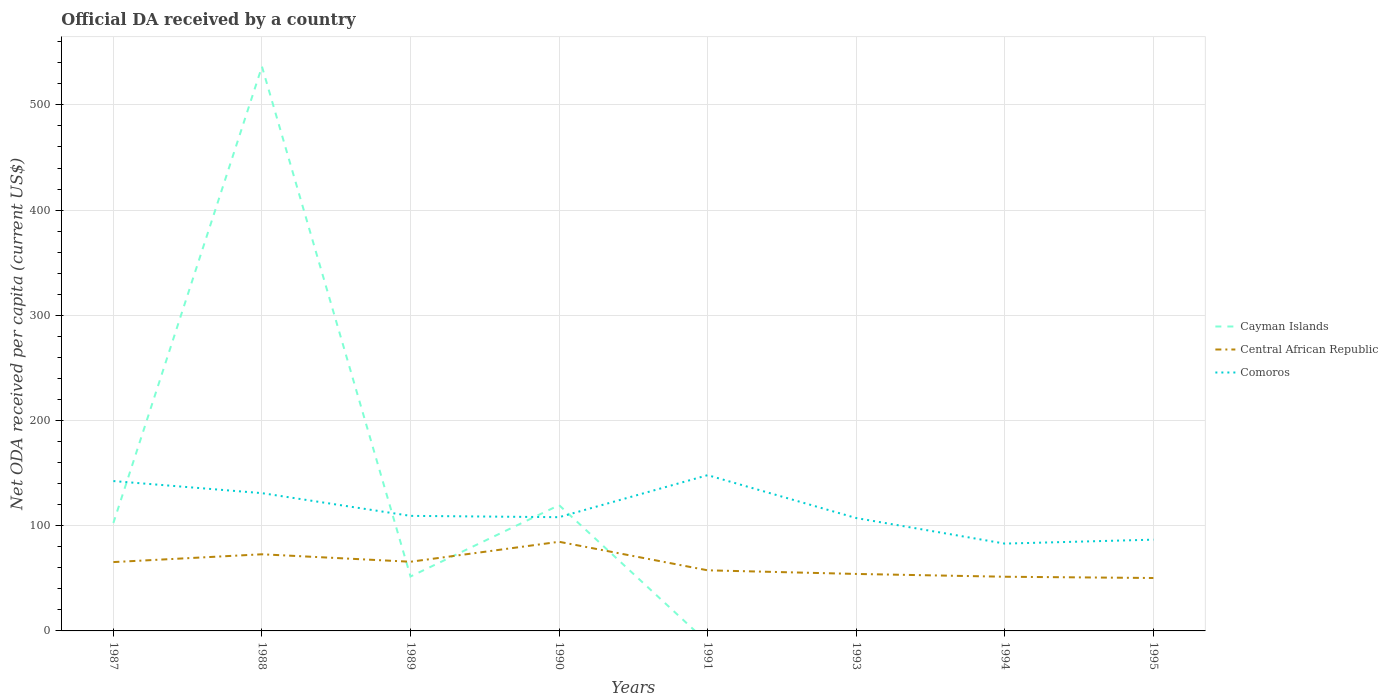Does the line corresponding to Comoros intersect with the line corresponding to Central African Republic?
Give a very brief answer. No. Across all years, what is the maximum ODA received in in Comoros?
Your response must be concise. 82.99. What is the total ODA received in in Comoros in the graph?
Provide a short and direct response. 25.11. What is the difference between the highest and the second highest ODA received in in Comoros?
Give a very brief answer. 65.06. What is the difference between the highest and the lowest ODA received in in Comoros?
Make the answer very short. 3. Are the values on the major ticks of Y-axis written in scientific E-notation?
Provide a short and direct response. No. Does the graph contain grids?
Offer a very short reply. Yes. How many legend labels are there?
Provide a short and direct response. 3. How are the legend labels stacked?
Make the answer very short. Vertical. What is the title of the graph?
Your response must be concise. Official DA received by a country. Does "United Kingdom" appear as one of the legend labels in the graph?
Provide a short and direct response. No. What is the label or title of the X-axis?
Ensure brevity in your answer.  Years. What is the label or title of the Y-axis?
Your answer should be very brief. Net ODA received per capita (current US$). What is the Net ODA received per capita (current US$) of Cayman Islands in 1987?
Provide a short and direct response. 102.61. What is the Net ODA received per capita (current US$) of Central African Republic in 1987?
Your answer should be compact. 65.43. What is the Net ODA received per capita (current US$) of Comoros in 1987?
Provide a short and direct response. 142.44. What is the Net ODA received per capita (current US$) of Cayman Islands in 1988?
Keep it short and to the point. 536.4. What is the Net ODA received per capita (current US$) in Central African Republic in 1988?
Provide a succinct answer. 72.85. What is the Net ODA received per capita (current US$) of Comoros in 1988?
Offer a terse response. 130.95. What is the Net ODA received per capita (current US$) in Cayman Islands in 1989?
Your answer should be very brief. 51.73. What is the Net ODA received per capita (current US$) of Central African Republic in 1989?
Keep it short and to the point. 65.75. What is the Net ODA received per capita (current US$) in Comoros in 1989?
Provide a succinct answer. 109.35. What is the Net ODA received per capita (current US$) of Cayman Islands in 1990?
Keep it short and to the point. 119.56. What is the Net ODA received per capita (current US$) of Central African Republic in 1990?
Your answer should be very brief. 84.72. What is the Net ODA received per capita (current US$) in Comoros in 1990?
Ensure brevity in your answer.  108.11. What is the Net ODA received per capita (current US$) of Central African Republic in 1991?
Provide a short and direct response. 57.6. What is the Net ODA received per capita (current US$) of Comoros in 1991?
Give a very brief answer. 148.05. What is the Net ODA received per capita (current US$) of Cayman Islands in 1993?
Make the answer very short. 0. What is the Net ODA received per capita (current US$) in Central African Republic in 1993?
Offer a terse response. 54.16. What is the Net ODA received per capita (current US$) in Comoros in 1993?
Your answer should be compact. 107.28. What is the Net ODA received per capita (current US$) of Cayman Islands in 1994?
Your answer should be very brief. 0. What is the Net ODA received per capita (current US$) in Central African Republic in 1994?
Offer a very short reply. 51.5. What is the Net ODA received per capita (current US$) in Comoros in 1994?
Make the answer very short. 82.99. What is the Net ODA received per capita (current US$) in Central African Republic in 1995?
Offer a terse response. 50.3. What is the Net ODA received per capita (current US$) in Comoros in 1995?
Keep it short and to the point. 86.74. Across all years, what is the maximum Net ODA received per capita (current US$) of Cayman Islands?
Provide a succinct answer. 536.4. Across all years, what is the maximum Net ODA received per capita (current US$) of Central African Republic?
Ensure brevity in your answer.  84.72. Across all years, what is the maximum Net ODA received per capita (current US$) of Comoros?
Your answer should be compact. 148.05. Across all years, what is the minimum Net ODA received per capita (current US$) of Cayman Islands?
Ensure brevity in your answer.  0. Across all years, what is the minimum Net ODA received per capita (current US$) of Central African Republic?
Provide a succinct answer. 50.3. Across all years, what is the minimum Net ODA received per capita (current US$) in Comoros?
Provide a succinct answer. 82.99. What is the total Net ODA received per capita (current US$) of Cayman Islands in the graph?
Ensure brevity in your answer.  810.3. What is the total Net ODA received per capita (current US$) of Central African Republic in the graph?
Give a very brief answer. 502.31. What is the total Net ODA received per capita (current US$) of Comoros in the graph?
Offer a very short reply. 915.93. What is the difference between the Net ODA received per capita (current US$) in Cayman Islands in 1987 and that in 1988?
Give a very brief answer. -433.79. What is the difference between the Net ODA received per capita (current US$) in Central African Republic in 1987 and that in 1988?
Make the answer very short. -7.42. What is the difference between the Net ODA received per capita (current US$) of Comoros in 1987 and that in 1988?
Give a very brief answer. 11.49. What is the difference between the Net ODA received per capita (current US$) in Cayman Islands in 1987 and that in 1989?
Make the answer very short. 50.88. What is the difference between the Net ODA received per capita (current US$) of Central African Republic in 1987 and that in 1989?
Provide a succinct answer. -0.32. What is the difference between the Net ODA received per capita (current US$) of Comoros in 1987 and that in 1989?
Offer a very short reply. 33.09. What is the difference between the Net ODA received per capita (current US$) in Cayman Islands in 1987 and that in 1990?
Make the answer very short. -16.95. What is the difference between the Net ODA received per capita (current US$) of Central African Republic in 1987 and that in 1990?
Give a very brief answer. -19.29. What is the difference between the Net ODA received per capita (current US$) of Comoros in 1987 and that in 1990?
Your answer should be compact. 34.34. What is the difference between the Net ODA received per capita (current US$) of Central African Republic in 1987 and that in 1991?
Your answer should be very brief. 7.83. What is the difference between the Net ODA received per capita (current US$) in Comoros in 1987 and that in 1991?
Provide a short and direct response. -5.61. What is the difference between the Net ODA received per capita (current US$) of Central African Republic in 1987 and that in 1993?
Provide a short and direct response. 11.27. What is the difference between the Net ODA received per capita (current US$) in Comoros in 1987 and that in 1993?
Provide a succinct answer. 35.16. What is the difference between the Net ODA received per capita (current US$) of Central African Republic in 1987 and that in 1994?
Ensure brevity in your answer.  13.93. What is the difference between the Net ODA received per capita (current US$) of Comoros in 1987 and that in 1994?
Provide a succinct answer. 59.45. What is the difference between the Net ODA received per capita (current US$) in Central African Republic in 1987 and that in 1995?
Keep it short and to the point. 15.13. What is the difference between the Net ODA received per capita (current US$) in Comoros in 1987 and that in 1995?
Ensure brevity in your answer.  55.7. What is the difference between the Net ODA received per capita (current US$) of Cayman Islands in 1988 and that in 1989?
Offer a terse response. 484.67. What is the difference between the Net ODA received per capita (current US$) in Central African Republic in 1988 and that in 1989?
Give a very brief answer. 7.1. What is the difference between the Net ODA received per capita (current US$) in Comoros in 1988 and that in 1989?
Keep it short and to the point. 21.6. What is the difference between the Net ODA received per capita (current US$) in Cayman Islands in 1988 and that in 1990?
Ensure brevity in your answer.  416.85. What is the difference between the Net ODA received per capita (current US$) in Central African Republic in 1988 and that in 1990?
Make the answer very short. -11.87. What is the difference between the Net ODA received per capita (current US$) in Comoros in 1988 and that in 1990?
Offer a terse response. 22.85. What is the difference between the Net ODA received per capita (current US$) in Central African Republic in 1988 and that in 1991?
Your response must be concise. 15.25. What is the difference between the Net ODA received per capita (current US$) of Comoros in 1988 and that in 1991?
Ensure brevity in your answer.  -17.1. What is the difference between the Net ODA received per capita (current US$) in Central African Republic in 1988 and that in 1993?
Your response must be concise. 18.69. What is the difference between the Net ODA received per capita (current US$) in Comoros in 1988 and that in 1993?
Offer a very short reply. 23.67. What is the difference between the Net ODA received per capita (current US$) in Central African Republic in 1988 and that in 1994?
Provide a succinct answer. 21.35. What is the difference between the Net ODA received per capita (current US$) of Comoros in 1988 and that in 1994?
Keep it short and to the point. 47.96. What is the difference between the Net ODA received per capita (current US$) in Central African Republic in 1988 and that in 1995?
Your answer should be very brief. 22.55. What is the difference between the Net ODA received per capita (current US$) of Comoros in 1988 and that in 1995?
Your answer should be compact. 44.21. What is the difference between the Net ODA received per capita (current US$) in Cayman Islands in 1989 and that in 1990?
Keep it short and to the point. -67.82. What is the difference between the Net ODA received per capita (current US$) of Central African Republic in 1989 and that in 1990?
Offer a terse response. -18.97. What is the difference between the Net ODA received per capita (current US$) in Comoros in 1989 and that in 1990?
Make the answer very short. 1.25. What is the difference between the Net ODA received per capita (current US$) in Central African Republic in 1989 and that in 1991?
Give a very brief answer. 8.14. What is the difference between the Net ODA received per capita (current US$) in Comoros in 1989 and that in 1991?
Make the answer very short. -38.7. What is the difference between the Net ODA received per capita (current US$) of Central African Republic in 1989 and that in 1993?
Ensure brevity in your answer.  11.58. What is the difference between the Net ODA received per capita (current US$) in Comoros in 1989 and that in 1993?
Keep it short and to the point. 2.07. What is the difference between the Net ODA received per capita (current US$) of Central African Republic in 1989 and that in 1994?
Make the answer very short. 14.25. What is the difference between the Net ODA received per capita (current US$) in Comoros in 1989 and that in 1994?
Your response must be concise. 26.36. What is the difference between the Net ODA received per capita (current US$) of Central African Republic in 1989 and that in 1995?
Give a very brief answer. 15.45. What is the difference between the Net ODA received per capita (current US$) in Comoros in 1989 and that in 1995?
Provide a succinct answer. 22.61. What is the difference between the Net ODA received per capita (current US$) of Central African Republic in 1990 and that in 1991?
Offer a very short reply. 27.12. What is the difference between the Net ODA received per capita (current US$) of Comoros in 1990 and that in 1991?
Provide a succinct answer. -39.94. What is the difference between the Net ODA received per capita (current US$) in Central African Republic in 1990 and that in 1993?
Make the answer very short. 30.56. What is the difference between the Net ODA received per capita (current US$) of Comoros in 1990 and that in 1993?
Give a very brief answer. 0.82. What is the difference between the Net ODA received per capita (current US$) of Central African Republic in 1990 and that in 1994?
Ensure brevity in your answer.  33.22. What is the difference between the Net ODA received per capita (current US$) of Comoros in 1990 and that in 1994?
Your answer should be compact. 25.11. What is the difference between the Net ODA received per capita (current US$) in Central African Republic in 1990 and that in 1995?
Offer a very short reply. 34.42. What is the difference between the Net ODA received per capita (current US$) of Comoros in 1990 and that in 1995?
Ensure brevity in your answer.  21.36. What is the difference between the Net ODA received per capita (current US$) in Central African Republic in 1991 and that in 1993?
Give a very brief answer. 3.44. What is the difference between the Net ODA received per capita (current US$) in Comoros in 1991 and that in 1993?
Offer a terse response. 40.77. What is the difference between the Net ODA received per capita (current US$) of Central African Republic in 1991 and that in 1994?
Keep it short and to the point. 6.1. What is the difference between the Net ODA received per capita (current US$) in Comoros in 1991 and that in 1994?
Keep it short and to the point. 65.06. What is the difference between the Net ODA received per capita (current US$) in Central African Republic in 1991 and that in 1995?
Provide a short and direct response. 7.31. What is the difference between the Net ODA received per capita (current US$) in Comoros in 1991 and that in 1995?
Make the answer very short. 61.31. What is the difference between the Net ODA received per capita (current US$) of Central African Republic in 1993 and that in 1994?
Your answer should be very brief. 2.66. What is the difference between the Net ODA received per capita (current US$) of Comoros in 1993 and that in 1994?
Provide a short and direct response. 24.29. What is the difference between the Net ODA received per capita (current US$) of Central African Republic in 1993 and that in 1995?
Offer a terse response. 3.87. What is the difference between the Net ODA received per capita (current US$) in Comoros in 1993 and that in 1995?
Ensure brevity in your answer.  20.54. What is the difference between the Net ODA received per capita (current US$) in Central African Republic in 1994 and that in 1995?
Your response must be concise. 1.2. What is the difference between the Net ODA received per capita (current US$) in Comoros in 1994 and that in 1995?
Your answer should be compact. -3.75. What is the difference between the Net ODA received per capita (current US$) in Cayman Islands in 1987 and the Net ODA received per capita (current US$) in Central African Republic in 1988?
Your answer should be very brief. 29.76. What is the difference between the Net ODA received per capita (current US$) in Cayman Islands in 1987 and the Net ODA received per capita (current US$) in Comoros in 1988?
Your answer should be very brief. -28.34. What is the difference between the Net ODA received per capita (current US$) in Central African Republic in 1987 and the Net ODA received per capita (current US$) in Comoros in 1988?
Offer a very short reply. -65.52. What is the difference between the Net ODA received per capita (current US$) in Cayman Islands in 1987 and the Net ODA received per capita (current US$) in Central African Republic in 1989?
Make the answer very short. 36.86. What is the difference between the Net ODA received per capita (current US$) of Cayman Islands in 1987 and the Net ODA received per capita (current US$) of Comoros in 1989?
Make the answer very short. -6.74. What is the difference between the Net ODA received per capita (current US$) in Central African Republic in 1987 and the Net ODA received per capita (current US$) in Comoros in 1989?
Provide a succinct answer. -43.92. What is the difference between the Net ODA received per capita (current US$) of Cayman Islands in 1987 and the Net ODA received per capita (current US$) of Central African Republic in 1990?
Ensure brevity in your answer.  17.89. What is the difference between the Net ODA received per capita (current US$) in Cayman Islands in 1987 and the Net ODA received per capita (current US$) in Comoros in 1990?
Your response must be concise. -5.5. What is the difference between the Net ODA received per capita (current US$) of Central African Republic in 1987 and the Net ODA received per capita (current US$) of Comoros in 1990?
Ensure brevity in your answer.  -42.68. What is the difference between the Net ODA received per capita (current US$) of Cayman Islands in 1987 and the Net ODA received per capita (current US$) of Central African Republic in 1991?
Your answer should be compact. 45.01. What is the difference between the Net ODA received per capita (current US$) of Cayman Islands in 1987 and the Net ODA received per capita (current US$) of Comoros in 1991?
Provide a short and direct response. -45.44. What is the difference between the Net ODA received per capita (current US$) of Central African Republic in 1987 and the Net ODA received per capita (current US$) of Comoros in 1991?
Your response must be concise. -82.62. What is the difference between the Net ODA received per capita (current US$) of Cayman Islands in 1987 and the Net ODA received per capita (current US$) of Central African Republic in 1993?
Keep it short and to the point. 48.45. What is the difference between the Net ODA received per capita (current US$) in Cayman Islands in 1987 and the Net ODA received per capita (current US$) in Comoros in 1993?
Provide a short and direct response. -4.67. What is the difference between the Net ODA received per capita (current US$) of Central African Republic in 1987 and the Net ODA received per capita (current US$) of Comoros in 1993?
Provide a short and direct response. -41.85. What is the difference between the Net ODA received per capita (current US$) in Cayman Islands in 1987 and the Net ODA received per capita (current US$) in Central African Republic in 1994?
Your answer should be very brief. 51.11. What is the difference between the Net ODA received per capita (current US$) of Cayman Islands in 1987 and the Net ODA received per capita (current US$) of Comoros in 1994?
Keep it short and to the point. 19.62. What is the difference between the Net ODA received per capita (current US$) in Central African Republic in 1987 and the Net ODA received per capita (current US$) in Comoros in 1994?
Give a very brief answer. -17.56. What is the difference between the Net ODA received per capita (current US$) in Cayman Islands in 1987 and the Net ODA received per capita (current US$) in Central African Republic in 1995?
Provide a succinct answer. 52.31. What is the difference between the Net ODA received per capita (current US$) of Cayman Islands in 1987 and the Net ODA received per capita (current US$) of Comoros in 1995?
Make the answer very short. 15.87. What is the difference between the Net ODA received per capita (current US$) of Central African Republic in 1987 and the Net ODA received per capita (current US$) of Comoros in 1995?
Your answer should be compact. -21.31. What is the difference between the Net ODA received per capita (current US$) of Cayman Islands in 1988 and the Net ODA received per capita (current US$) of Central African Republic in 1989?
Your answer should be very brief. 470.66. What is the difference between the Net ODA received per capita (current US$) in Cayman Islands in 1988 and the Net ODA received per capita (current US$) in Comoros in 1989?
Keep it short and to the point. 427.05. What is the difference between the Net ODA received per capita (current US$) in Central African Republic in 1988 and the Net ODA received per capita (current US$) in Comoros in 1989?
Provide a short and direct response. -36.5. What is the difference between the Net ODA received per capita (current US$) in Cayman Islands in 1988 and the Net ODA received per capita (current US$) in Central African Republic in 1990?
Offer a very short reply. 451.68. What is the difference between the Net ODA received per capita (current US$) in Cayman Islands in 1988 and the Net ODA received per capita (current US$) in Comoros in 1990?
Your response must be concise. 428.3. What is the difference between the Net ODA received per capita (current US$) in Central African Republic in 1988 and the Net ODA received per capita (current US$) in Comoros in 1990?
Make the answer very short. -35.26. What is the difference between the Net ODA received per capita (current US$) of Cayman Islands in 1988 and the Net ODA received per capita (current US$) of Central African Republic in 1991?
Offer a terse response. 478.8. What is the difference between the Net ODA received per capita (current US$) in Cayman Islands in 1988 and the Net ODA received per capita (current US$) in Comoros in 1991?
Your answer should be compact. 388.35. What is the difference between the Net ODA received per capita (current US$) of Central African Republic in 1988 and the Net ODA received per capita (current US$) of Comoros in 1991?
Offer a terse response. -75.2. What is the difference between the Net ODA received per capita (current US$) in Cayman Islands in 1988 and the Net ODA received per capita (current US$) in Central African Republic in 1993?
Offer a very short reply. 482.24. What is the difference between the Net ODA received per capita (current US$) of Cayman Islands in 1988 and the Net ODA received per capita (current US$) of Comoros in 1993?
Your response must be concise. 429.12. What is the difference between the Net ODA received per capita (current US$) in Central African Republic in 1988 and the Net ODA received per capita (current US$) in Comoros in 1993?
Provide a succinct answer. -34.43. What is the difference between the Net ODA received per capita (current US$) of Cayman Islands in 1988 and the Net ODA received per capita (current US$) of Central African Republic in 1994?
Give a very brief answer. 484.91. What is the difference between the Net ODA received per capita (current US$) in Cayman Islands in 1988 and the Net ODA received per capita (current US$) in Comoros in 1994?
Keep it short and to the point. 453.41. What is the difference between the Net ODA received per capita (current US$) of Central African Republic in 1988 and the Net ODA received per capita (current US$) of Comoros in 1994?
Provide a succinct answer. -10.14. What is the difference between the Net ODA received per capita (current US$) of Cayman Islands in 1988 and the Net ODA received per capita (current US$) of Central African Republic in 1995?
Offer a terse response. 486.11. What is the difference between the Net ODA received per capita (current US$) in Cayman Islands in 1988 and the Net ODA received per capita (current US$) in Comoros in 1995?
Keep it short and to the point. 449.66. What is the difference between the Net ODA received per capita (current US$) of Central African Republic in 1988 and the Net ODA received per capita (current US$) of Comoros in 1995?
Your answer should be very brief. -13.89. What is the difference between the Net ODA received per capita (current US$) of Cayman Islands in 1989 and the Net ODA received per capita (current US$) of Central African Republic in 1990?
Make the answer very short. -32.99. What is the difference between the Net ODA received per capita (current US$) of Cayman Islands in 1989 and the Net ODA received per capita (current US$) of Comoros in 1990?
Provide a succinct answer. -56.37. What is the difference between the Net ODA received per capita (current US$) in Central African Republic in 1989 and the Net ODA received per capita (current US$) in Comoros in 1990?
Offer a very short reply. -42.36. What is the difference between the Net ODA received per capita (current US$) of Cayman Islands in 1989 and the Net ODA received per capita (current US$) of Central African Republic in 1991?
Make the answer very short. -5.87. What is the difference between the Net ODA received per capita (current US$) of Cayman Islands in 1989 and the Net ODA received per capita (current US$) of Comoros in 1991?
Keep it short and to the point. -96.32. What is the difference between the Net ODA received per capita (current US$) in Central African Republic in 1989 and the Net ODA received per capita (current US$) in Comoros in 1991?
Your response must be concise. -82.3. What is the difference between the Net ODA received per capita (current US$) in Cayman Islands in 1989 and the Net ODA received per capita (current US$) in Central African Republic in 1993?
Offer a terse response. -2.43. What is the difference between the Net ODA received per capita (current US$) of Cayman Islands in 1989 and the Net ODA received per capita (current US$) of Comoros in 1993?
Offer a very short reply. -55.55. What is the difference between the Net ODA received per capita (current US$) in Central African Republic in 1989 and the Net ODA received per capita (current US$) in Comoros in 1993?
Make the answer very short. -41.54. What is the difference between the Net ODA received per capita (current US$) of Cayman Islands in 1989 and the Net ODA received per capita (current US$) of Central African Republic in 1994?
Your answer should be compact. 0.23. What is the difference between the Net ODA received per capita (current US$) of Cayman Islands in 1989 and the Net ODA received per capita (current US$) of Comoros in 1994?
Give a very brief answer. -31.26. What is the difference between the Net ODA received per capita (current US$) of Central African Republic in 1989 and the Net ODA received per capita (current US$) of Comoros in 1994?
Ensure brevity in your answer.  -17.25. What is the difference between the Net ODA received per capita (current US$) in Cayman Islands in 1989 and the Net ODA received per capita (current US$) in Central African Republic in 1995?
Offer a terse response. 1.44. What is the difference between the Net ODA received per capita (current US$) in Cayman Islands in 1989 and the Net ODA received per capita (current US$) in Comoros in 1995?
Keep it short and to the point. -35.01. What is the difference between the Net ODA received per capita (current US$) in Central African Republic in 1989 and the Net ODA received per capita (current US$) in Comoros in 1995?
Offer a very short reply. -21. What is the difference between the Net ODA received per capita (current US$) in Cayman Islands in 1990 and the Net ODA received per capita (current US$) in Central African Republic in 1991?
Ensure brevity in your answer.  61.95. What is the difference between the Net ODA received per capita (current US$) of Cayman Islands in 1990 and the Net ODA received per capita (current US$) of Comoros in 1991?
Provide a succinct answer. -28.49. What is the difference between the Net ODA received per capita (current US$) in Central African Republic in 1990 and the Net ODA received per capita (current US$) in Comoros in 1991?
Your response must be concise. -63.33. What is the difference between the Net ODA received per capita (current US$) in Cayman Islands in 1990 and the Net ODA received per capita (current US$) in Central African Republic in 1993?
Offer a terse response. 65.39. What is the difference between the Net ODA received per capita (current US$) in Cayman Islands in 1990 and the Net ODA received per capita (current US$) in Comoros in 1993?
Keep it short and to the point. 12.27. What is the difference between the Net ODA received per capita (current US$) of Central African Republic in 1990 and the Net ODA received per capita (current US$) of Comoros in 1993?
Your response must be concise. -22.57. What is the difference between the Net ODA received per capita (current US$) of Cayman Islands in 1990 and the Net ODA received per capita (current US$) of Central African Republic in 1994?
Make the answer very short. 68.06. What is the difference between the Net ODA received per capita (current US$) in Cayman Islands in 1990 and the Net ODA received per capita (current US$) in Comoros in 1994?
Your answer should be compact. 36.56. What is the difference between the Net ODA received per capita (current US$) of Central African Republic in 1990 and the Net ODA received per capita (current US$) of Comoros in 1994?
Offer a terse response. 1.73. What is the difference between the Net ODA received per capita (current US$) of Cayman Islands in 1990 and the Net ODA received per capita (current US$) of Central African Republic in 1995?
Offer a terse response. 69.26. What is the difference between the Net ODA received per capita (current US$) in Cayman Islands in 1990 and the Net ODA received per capita (current US$) in Comoros in 1995?
Provide a succinct answer. 32.81. What is the difference between the Net ODA received per capita (current US$) of Central African Republic in 1990 and the Net ODA received per capita (current US$) of Comoros in 1995?
Make the answer very short. -2.02. What is the difference between the Net ODA received per capita (current US$) in Central African Republic in 1991 and the Net ODA received per capita (current US$) in Comoros in 1993?
Your answer should be very brief. -49.68. What is the difference between the Net ODA received per capita (current US$) of Central African Republic in 1991 and the Net ODA received per capita (current US$) of Comoros in 1994?
Offer a terse response. -25.39. What is the difference between the Net ODA received per capita (current US$) in Central African Republic in 1991 and the Net ODA received per capita (current US$) in Comoros in 1995?
Your answer should be compact. -29.14. What is the difference between the Net ODA received per capita (current US$) of Central African Republic in 1993 and the Net ODA received per capita (current US$) of Comoros in 1994?
Keep it short and to the point. -28.83. What is the difference between the Net ODA received per capita (current US$) in Central African Republic in 1993 and the Net ODA received per capita (current US$) in Comoros in 1995?
Your answer should be very brief. -32.58. What is the difference between the Net ODA received per capita (current US$) of Central African Republic in 1994 and the Net ODA received per capita (current US$) of Comoros in 1995?
Your answer should be very brief. -35.25. What is the average Net ODA received per capita (current US$) in Cayman Islands per year?
Offer a terse response. 101.29. What is the average Net ODA received per capita (current US$) in Central African Republic per year?
Provide a short and direct response. 62.79. What is the average Net ODA received per capita (current US$) of Comoros per year?
Ensure brevity in your answer.  114.49. In the year 1987, what is the difference between the Net ODA received per capita (current US$) of Cayman Islands and Net ODA received per capita (current US$) of Central African Republic?
Offer a terse response. 37.18. In the year 1987, what is the difference between the Net ODA received per capita (current US$) in Cayman Islands and Net ODA received per capita (current US$) in Comoros?
Your answer should be very brief. -39.83. In the year 1987, what is the difference between the Net ODA received per capita (current US$) of Central African Republic and Net ODA received per capita (current US$) of Comoros?
Your answer should be compact. -77.01. In the year 1988, what is the difference between the Net ODA received per capita (current US$) of Cayman Islands and Net ODA received per capita (current US$) of Central African Republic?
Ensure brevity in your answer.  463.55. In the year 1988, what is the difference between the Net ODA received per capita (current US$) of Cayman Islands and Net ODA received per capita (current US$) of Comoros?
Keep it short and to the point. 405.45. In the year 1988, what is the difference between the Net ODA received per capita (current US$) in Central African Republic and Net ODA received per capita (current US$) in Comoros?
Make the answer very short. -58.1. In the year 1989, what is the difference between the Net ODA received per capita (current US$) in Cayman Islands and Net ODA received per capita (current US$) in Central African Republic?
Provide a succinct answer. -14.01. In the year 1989, what is the difference between the Net ODA received per capita (current US$) of Cayman Islands and Net ODA received per capita (current US$) of Comoros?
Provide a succinct answer. -57.62. In the year 1989, what is the difference between the Net ODA received per capita (current US$) in Central African Republic and Net ODA received per capita (current US$) in Comoros?
Make the answer very short. -43.61. In the year 1990, what is the difference between the Net ODA received per capita (current US$) in Cayman Islands and Net ODA received per capita (current US$) in Central African Republic?
Your response must be concise. 34.84. In the year 1990, what is the difference between the Net ODA received per capita (current US$) in Cayman Islands and Net ODA received per capita (current US$) in Comoros?
Your response must be concise. 11.45. In the year 1990, what is the difference between the Net ODA received per capita (current US$) in Central African Republic and Net ODA received per capita (current US$) in Comoros?
Give a very brief answer. -23.39. In the year 1991, what is the difference between the Net ODA received per capita (current US$) in Central African Republic and Net ODA received per capita (current US$) in Comoros?
Your answer should be compact. -90.45. In the year 1993, what is the difference between the Net ODA received per capita (current US$) in Central African Republic and Net ODA received per capita (current US$) in Comoros?
Keep it short and to the point. -53.12. In the year 1994, what is the difference between the Net ODA received per capita (current US$) in Central African Republic and Net ODA received per capita (current US$) in Comoros?
Ensure brevity in your answer.  -31.49. In the year 1995, what is the difference between the Net ODA received per capita (current US$) in Central African Republic and Net ODA received per capita (current US$) in Comoros?
Provide a short and direct response. -36.45. What is the ratio of the Net ODA received per capita (current US$) in Cayman Islands in 1987 to that in 1988?
Keep it short and to the point. 0.19. What is the ratio of the Net ODA received per capita (current US$) in Central African Republic in 1987 to that in 1988?
Provide a short and direct response. 0.9. What is the ratio of the Net ODA received per capita (current US$) in Comoros in 1987 to that in 1988?
Provide a short and direct response. 1.09. What is the ratio of the Net ODA received per capita (current US$) of Cayman Islands in 1987 to that in 1989?
Offer a very short reply. 1.98. What is the ratio of the Net ODA received per capita (current US$) of Central African Republic in 1987 to that in 1989?
Keep it short and to the point. 1. What is the ratio of the Net ODA received per capita (current US$) of Comoros in 1987 to that in 1989?
Your answer should be compact. 1.3. What is the ratio of the Net ODA received per capita (current US$) in Cayman Islands in 1987 to that in 1990?
Provide a short and direct response. 0.86. What is the ratio of the Net ODA received per capita (current US$) of Central African Republic in 1987 to that in 1990?
Make the answer very short. 0.77. What is the ratio of the Net ODA received per capita (current US$) of Comoros in 1987 to that in 1990?
Make the answer very short. 1.32. What is the ratio of the Net ODA received per capita (current US$) of Central African Republic in 1987 to that in 1991?
Your answer should be compact. 1.14. What is the ratio of the Net ODA received per capita (current US$) of Comoros in 1987 to that in 1991?
Your answer should be very brief. 0.96. What is the ratio of the Net ODA received per capita (current US$) of Central African Republic in 1987 to that in 1993?
Your response must be concise. 1.21. What is the ratio of the Net ODA received per capita (current US$) of Comoros in 1987 to that in 1993?
Offer a terse response. 1.33. What is the ratio of the Net ODA received per capita (current US$) in Central African Republic in 1987 to that in 1994?
Keep it short and to the point. 1.27. What is the ratio of the Net ODA received per capita (current US$) of Comoros in 1987 to that in 1994?
Give a very brief answer. 1.72. What is the ratio of the Net ODA received per capita (current US$) of Central African Republic in 1987 to that in 1995?
Provide a short and direct response. 1.3. What is the ratio of the Net ODA received per capita (current US$) of Comoros in 1987 to that in 1995?
Provide a succinct answer. 1.64. What is the ratio of the Net ODA received per capita (current US$) of Cayman Islands in 1988 to that in 1989?
Offer a terse response. 10.37. What is the ratio of the Net ODA received per capita (current US$) of Central African Republic in 1988 to that in 1989?
Make the answer very short. 1.11. What is the ratio of the Net ODA received per capita (current US$) in Comoros in 1988 to that in 1989?
Give a very brief answer. 1.2. What is the ratio of the Net ODA received per capita (current US$) of Cayman Islands in 1988 to that in 1990?
Offer a terse response. 4.49. What is the ratio of the Net ODA received per capita (current US$) in Central African Republic in 1988 to that in 1990?
Give a very brief answer. 0.86. What is the ratio of the Net ODA received per capita (current US$) of Comoros in 1988 to that in 1990?
Provide a succinct answer. 1.21. What is the ratio of the Net ODA received per capita (current US$) in Central African Republic in 1988 to that in 1991?
Offer a terse response. 1.26. What is the ratio of the Net ODA received per capita (current US$) in Comoros in 1988 to that in 1991?
Provide a short and direct response. 0.88. What is the ratio of the Net ODA received per capita (current US$) of Central African Republic in 1988 to that in 1993?
Your response must be concise. 1.34. What is the ratio of the Net ODA received per capita (current US$) in Comoros in 1988 to that in 1993?
Your answer should be compact. 1.22. What is the ratio of the Net ODA received per capita (current US$) of Central African Republic in 1988 to that in 1994?
Provide a short and direct response. 1.41. What is the ratio of the Net ODA received per capita (current US$) in Comoros in 1988 to that in 1994?
Provide a succinct answer. 1.58. What is the ratio of the Net ODA received per capita (current US$) in Central African Republic in 1988 to that in 1995?
Provide a short and direct response. 1.45. What is the ratio of the Net ODA received per capita (current US$) of Comoros in 1988 to that in 1995?
Offer a very short reply. 1.51. What is the ratio of the Net ODA received per capita (current US$) in Cayman Islands in 1989 to that in 1990?
Your answer should be compact. 0.43. What is the ratio of the Net ODA received per capita (current US$) of Central African Republic in 1989 to that in 1990?
Provide a short and direct response. 0.78. What is the ratio of the Net ODA received per capita (current US$) in Comoros in 1989 to that in 1990?
Offer a terse response. 1.01. What is the ratio of the Net ODA received per capita (current US$) in Central African Republic in 1989 to that in 1991?
Your answer should be very brief. 1.14. What is the ratio of the Net ODA received per capita (current US$) of Comoros in 1989 to that in 1991?
Ensure brevity in your answer.  0.74. What is the ratio of the Net ODA received per capita (current US$) of Central African Republic in 1989 to that in 1993?
Your answer should be very brief. 1.21. What is the ratio of the Net ODA received per capita (current US$) in Comoros in 1989 to that in 1993?
Keep it short and to the point. 1.02. What is the ratio of the Net ODA received per capita (current US$) of Central African Republic in 1989 to that in 1994?
Your answer should be compact. 1.28. What is the ratio of the Net ODA received per capita (current US$) of Comoros in 1989 to that in 1994?
Make the answer very short. 1.32. What is the ratio of the Net ODA received per capita (current US$) of Central African Republic in 1989 to that in 1995?
Offer a very short reply. 1.31. What is the ratio of the Net ODA received per capita (current US$) in Comoros in 1989 to that in 1995?
Your answer should be compact. 1.26. What is the ratio of the Net ODA received per capita (current US$) in Central African Republic in 1990 to that in 1991?
Your answer should be very brief. 1.47. What is the ratio of the Net ODA received per capita (current US$) of Comoros in 1990 to that in 1991?
Provide a succinct answer. 0.73. What is the ratio of the Net ODA received per capita (current US$) of Central African Republic in 1990 to that in 1993?
Make the answer very short. 1.56. What is the ratio of the Net ODA received per capita (current US$) of Comoros in 1990 to that in 1993?
Your response must be concise. 1.01. What is the ratio of the Net ODA received per capita (current US$) in Central African Republic in 1990 to that in 1994?
Make the answer very short. 1.65. What is the ratio of the Net ODA received per capita (current US$) in Comoros in 1990 to that in 1994?
Provide a short and direct response. 1.3. What is the ratio of the Net ODA received per capita (current US$) of Central African Republic in 1990 to that in 1995?
Provide a succinct answer. 1.68. What is the ratio of the Net ODA received per capita (current US$) in Comoros in 1990 to that in 1995?
Provide a succinct answer. 1.25. What is the ratio of the Net ODA received per capita (current US$) in Central African Republic in 1991 to that in 1993?
Your answer should be compact. 1.06. What is the ratio of the Net ODA received per capita (current US$) of Comoros in 1991 to that in 1993?
Ensure brevity in your answer.  1.38. What is the ratio of the Net ODA received per capita (current US$) of Central African Republic in 1991 to that in 1994?
Your answer should be very brief. 1.12. What is the ratio of the Net ODA received per capita (current US$) of Comoros in 1991 to that in 1994?
Your answer should be very brief. 1.78. What is the ratio of the Net ODA received per capita (current US$) in Central African Republic in 1991 to that in 1995?
Give a very brief answer. 1.15. What is the ratio of the Net ODA received per capita (current US$) in Comoros in 1991 to that in 1995?
Make the answer very short. 1.71. What is the ratio of the Net ODA received per capita (current US$) in Central African Republic in 1993 to that in 1994?
Ensure brevity in your answer.  1.05. What is the ratio of the Net ODA received per capita (current US$) in Comoros in 1993 to that in 1994?
Provide a succinct answer. 1.29. What is the ratio of the Net ODA received per capita (current US$) in Central African Republic in 1993 to that in 1995?
Your answer should be compact. 1.08. What is the ratio of the Net ODA received per capita (current US$) in Comoros in 1993 to that in 1995?
Offer a terse response. 1.24. What is the ratio of the Net ODA received per capita (current US$) of Central African Republic in 1994 to that in 1995?
Keep it short and to the point. 1.02. What is the ratio of the Net ODA received per capita (current US$) in Comoros in 1994 to that in 1995?
Keep it short and to the point. 0.96. What is the difference between the highest and the second highest Net ODA received per capita (current US$) in Cayman Islands?
Provide a short and direct response. 416.85. What is the difference between the highest and the second highest Net ODA received per capita (current US$) in Central African Republic?
Make the answer very short. 11.87. What is the difference between the highest and the second highest Net ODA received per capita (current US$) of Comoros?
Your response must be concise. 5.61. What is the difference between the highest and the lowest Net ODA received per capita (current US$) in Cayman Islands?
Provide a short and direct response. 536.4. What is the difference between the highest and the lowest Net ODA received per capita (current US$) in Central African Republic?
Give a very brief answer. 34.42. What is the difference between the highest and the lowest Net ODA received per capita (current US$) in Comoros?
Keep it short and to the point. 65.06. 